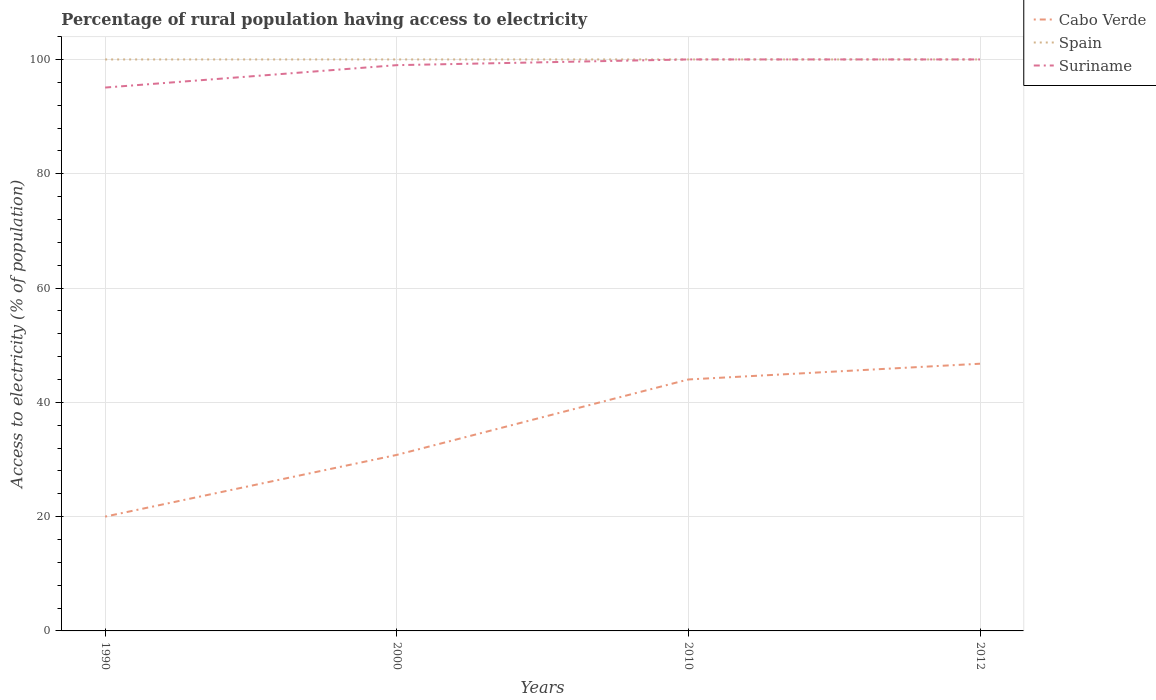How many different coloured lines are there?
Your response must be concise. 3. Across all years, what is the maximum percentage of rural population having access to electricity in Suriname?
Your answer should be very brief. 95.08. What is the total percentage of rural population having access to electricity in Cabo Verde in the graph?
Ensure brevity in your answer.  -15.95. What is the difference between the highest and the second highest percentage of rural population having access to electricity in Cabo Verde?
Your answer should be compact. 26.75. Is the percentage of rural population having access to electricity in Cabo Verde strictly greater than the percentage of rural population having access to electricity in Spain over the years?
Your response must be concise. Yes. How many lines are there?
Keep it short and to the point. 3. What is the difference between two consecutive major ticks on the Y-axis?
Offer a very short reply. 20. Does the graph contain any zero values?
Your response must be concise. No. Does the graph contain grids?
Provide a short and direct response. Yes. How many legend labels are there?
Keep it short and to the point. 3. How are the legend labels stacked?
Your answer should be very brief. Vertical. What is the title of the graph?
Provide a short and direct response. Percentage of rural population having access to electricity. Does "Micronesia" appear as one of the legend labels in the graph?
Give a very brief answer. No. What is the label or title of the X-axis?
Your answer should be very brief. Years. What is the label or title of the Y-axis?
Your response must be concise. Access to electricity (% of population). What is the Access to electricity (% of population) in Spain in 1990?
Offer a very short reply. 100. What is the Access to electricity (% of population) of Suriname in 1990?
Provide a short and direct response. 95.08. What is the Access to electricity (% of population) in Cabo Verde in 2000?
Offer a very short reply. 30.8. What is the Access to electricity (% of population) in Spain in 2000?
Your answer should be compact. 100. What is the Access to electricity (% of population) of Spain in 2010?
Provide a succinct answer. 100. What is the Access to electricity (% of population) of Cabo Verde in 2012?
Offer a terse response. 46.75. What is the Access to electricity (% of population) of Suriname in 2012?
Offer a terse response. 100. Across all years, what is the maximum Access to electricity (% of population) of Cabo Verde?
Provide a short and direct response. 46.75. Across all years, what is the maximum Access to electricity (% of population) of Suriname?
Offer a very short reply. 100. Across all years, what is the minimum Access to electricity (% of population) of Suriname?
Offer a terse response. 95.08. What is the total Access to electricity (% of population) of Cabo Verde in the graph?
Provide a short and direct response. 141.55. What is the total Access to electricity (% of population) in Suriname in the graph?
Your answer should be compact. 394.08. What is the difference between the Access to electricity (% of population) of Spain in 1990 and that in 2000?
Ensure brevity in your answer.  0. What is the difference between the Access to electricity (% of population) in Suriname in 1990 and that in 2000?
Provide a short and direct response. -3.92. What is the difference between the Access to electricity (% of population) in Cabo Verde in 1990 and that in 2010?
Offer a very short reply. -24. What is the difference between the Access to electricity (% of population) in Spain in 1990 and that in 2010?
Provide a succinct answer. 0. What is the difference between the Access to electricity (% of population) in Suriname in 1990 and that in 2010?
Make the answer very short. -4.92. What is the difference between the Access to electricity (% of population) in Cabo Verde in 1990 and that in 2012?
Offer a very short reply. -26.75. What is the difference between the Access to electricity (% of population) in Suriname in 1990 and that in 2012?
Offer a very short reply. -4.92. What is the difference between the Access to electricity (% of population) in Cabo Verde in 2000 and that in 2010?
Keep it short and to the point. -13.2. What is the difference between the Access to electricity (% of population) of Cabo Verde in 2000 and that in 2012?
Offer a very short reply. -15.95. What is the difference between the Access to electricity (% of population) in Spain in 2000 and that in 2012?
Give a very brief answer. 0. What is the difference between the Access to electricity (% of population) in Suriname in 2000 and that in 2012?
Your answer should be compact. -1. What is the difference between the Access to electricity (% of population) in Cabo Verde in 2010 and that in 2012?
Your answer should be compact. -2.75. What is the difference between the Access to electricity (% of population) in Spain in 2010 and that in 2012?
Give a very brief answer. 0. What is the difference between the Access to electricity (% of population) of Cabo Verde in 1990 and the Access to electricity (% of population) of Spain in 2000?
Offer a very short reply. -80. What is the difference between the Access to electricity (% of population) in Cabo Verde in 1990 and the Access to electricity (% of population) in Suriname in 2000?
Give a very brief answer. -79. What is the difference between the Access to electricity (% of population) in Cabo Verde in 1990 and the Access to electricity (% of population) in Spain in 2010?
Make the answer very short. -80. What is the difference between the Access to electricity (% of population) in Cabo Verde in 1990 and the Access to electricity (% of population) in Suriname in 2010?
Provide a succinct answer. -80. What is the difference between the Access to electricity (% of population) in Spain in 1990 and the Access to electricity (% of population) in Suriname in 2010?
Your response must be concise. 0. What is the difference between the Access to electricity (% of population) of Cabo Verde in 1990 and the Access to electricity (% of population) of Spain in 2012?
Offer a very short reply. -80. What is the difference between the Access to electricity (% of population) of Cabo Verde in 1990 and the Access to electricity (% of population) of Suriname in 2012?
Ensure brevity in your answer.  -80. What is the difference between the Access to electricity (% of population) of Spain in 1990 and the Access to electricity (% of population) of Suriname in 2012?
Offer a very short reply. 0. What is the difference between the Access to electricity (% of population) in Cabo Verde in 2000 and the Access to electricity (% of population) in Spain in 2010?
Provide a succinct answer. -69.2. What is the difference between the Access to electricity (% of population) of Cabo Verde in 2000 and the Access to electricity (% of population) of Suriname in 2010?
Your answer should be very brief. -69.2. What is the difference between the Access to electricity (% of population) of Cabo Verde in 2000 and the Access to electricity (% of population) of Spain in 2012?
Your answer should be compact. -69.2. What is the difference between the Access to electricity (% of population) of Cabo Verde in 2000 and the Access to electricity (% of population) of Suriname in 2012?
Your answer should be compact. -69.2. What is the difference between the Access to electricity (% of population) of Spain in 2000 and the Access to electricity (% of population) of Suriname in 2012?
Your answer should be compact. 0. What is the difference between the Access to electricity (% of population) in Cabo Verde in 2010 and the Access to electricity (% of population) in Spain in 2012?
Make the answer very short. -56. What is the difference between the Access to electricity (% of population) of Cabo Verde in 2010 and the Access to electricity (% of population) of Suriname in 2012?
Your answer should be very brief. -56. What is the average Access to electricity (% of population) in Cabo Verde per year?
Offer a very short reply. 35.39. What is the average Access to electricity (% of population) in Spain per year?
Ensure brevity in your answer.  100. What is the average Access to electricity (% of population) of Suriname per year?
Provide a short and direct response. 98.52. In the year 1990, what is the difference between the Access to electricity (% of population) of Cabo Verde and Access to electricity (% of population) of Spain?
Your response must be concise. -80. In the year 1990, what is the difference between the Access to electricity (% of population) of Cabo Verde and Access to electricity (% of population) of Suriname?
Make the answer very short. -75.08. In the year 1990, what is the difference between the Access to electricity (% of population) of Spain and Access to electricity (% of population) of Suriname?
Provide a succinct answer. 4.92. In the year 2000, what is the difference between the Access to electricity (% of population) in Cabo Verde and Access to electricity (% of population) in Spain?
Keep it short and to the point. -69.2. In the year 2000, what is the difference between the Access to electricity (% of population) of Cabo Verde and Access to electricity (% of population) of Suriname?
Offer a terse response. -68.2. In the year 2010, what is the difference between the Access to electricity (% of population) of Cabo Verde and Access to electricity (% of population) of Spain?
Provide a short and direct response. -56. In the year 2010, what is the difference between the Access to electricity (% of population) of Cabo Verde and Access to electricity (% of population) of Suriname?
Make the answer very short. -56. In the year 2012, what is the difference between the Access to electricity (% of population) in Cabo Verde and Access to electricity (% of population) in Spain?
Provide a succinct answer. -53.25. In the year 2012, what is the difference between the Access to electricity (% of population) of Cabo Verde and Access to electricity (% of population) of Suriname?
Offer a terse response. -53.25. In the year 2012, what is the difference between the Access to electricity (% of population) of Spain and Access to electricity (% of population) of Suriname?
Your answer should be compact. 0. What is the ratio of the Access to electricity (% of population) in Cabo Verde in 1990 to that in 2000?
Offer a terse response. 0.65. What is the ratio of the Access to electricity (% of population) of Suriname in 1990 to that in 2000?
Provide a succinct answer. 0.96. What is the ratio of the Access to electricity (% of population) in Cabo Verde in 1990 to that in 2010?
Keep it short and to the point. 0.45. What is the ratio of the Access to electricity (% of population) in Suriname in 1990 to that in 2010?
Provide a short and direct response. 0.95. What is the ratio of the Access to electricity (% of population) of Cabo Verde in 1990 to that in 2012?
Provide a short and direct response. 0.43. What is the ratio of the Access to electricity (% of population) in Spain in 1990 to that in 2012?
Your answer should be compact. 1. What is the ratio of the Access to electricity (% of population) in Suriname in 1990 to that in 2012?
Your response must be concise. 0.95. What is the ratio of the Access to electricity (% of population) in Cabo Verde in 2000 to that in 2010?
Ensure brevity in your answer.  0.7. What is the ratio of the Access to electricity (% of population) in Cabo Verde in 2000 to that in 2012?
Your answer should be compact. 0.66. What is the ratio of the Access to electricity (% of population) in Suriname in 2000 to that in 2012?
Provide a succinct answer. 0.99. What is the ratio of the Access to electricity (% of population) of Cabo Verde in 2010 to that in 2012?
Your response must be concise. 0.94. What is the ratio of the Access to electricity (% of population) of Spain in 2010 to that in 2012?
Make the answer very short. 1. What is the ratio of the Access to electricity (% of population) in Suriname in 2010 to that in 2012?
Your response must be concise. 1. What is the difference between the highest and the second highest Access to electricity (% of population) of Cabo Verde?
Make the answer very short. 2.75. What is the difference between the highest and the second highest Access to electricity (% of population) in Suriname?
Make the answer very short. 0. What is the difference between the highest and the lowest Access to electricity (% of population) of Cabo Verde?
Your answer should be very brief. 26.75. What is the difference between the highest and the lowest Access to electricity (% of population) of Spain?
Make the answer very short. 0. What is the difference between the highest and the lowest Access to electricity (% of population) of Suriname?
Your response must be concise. 4.92. 